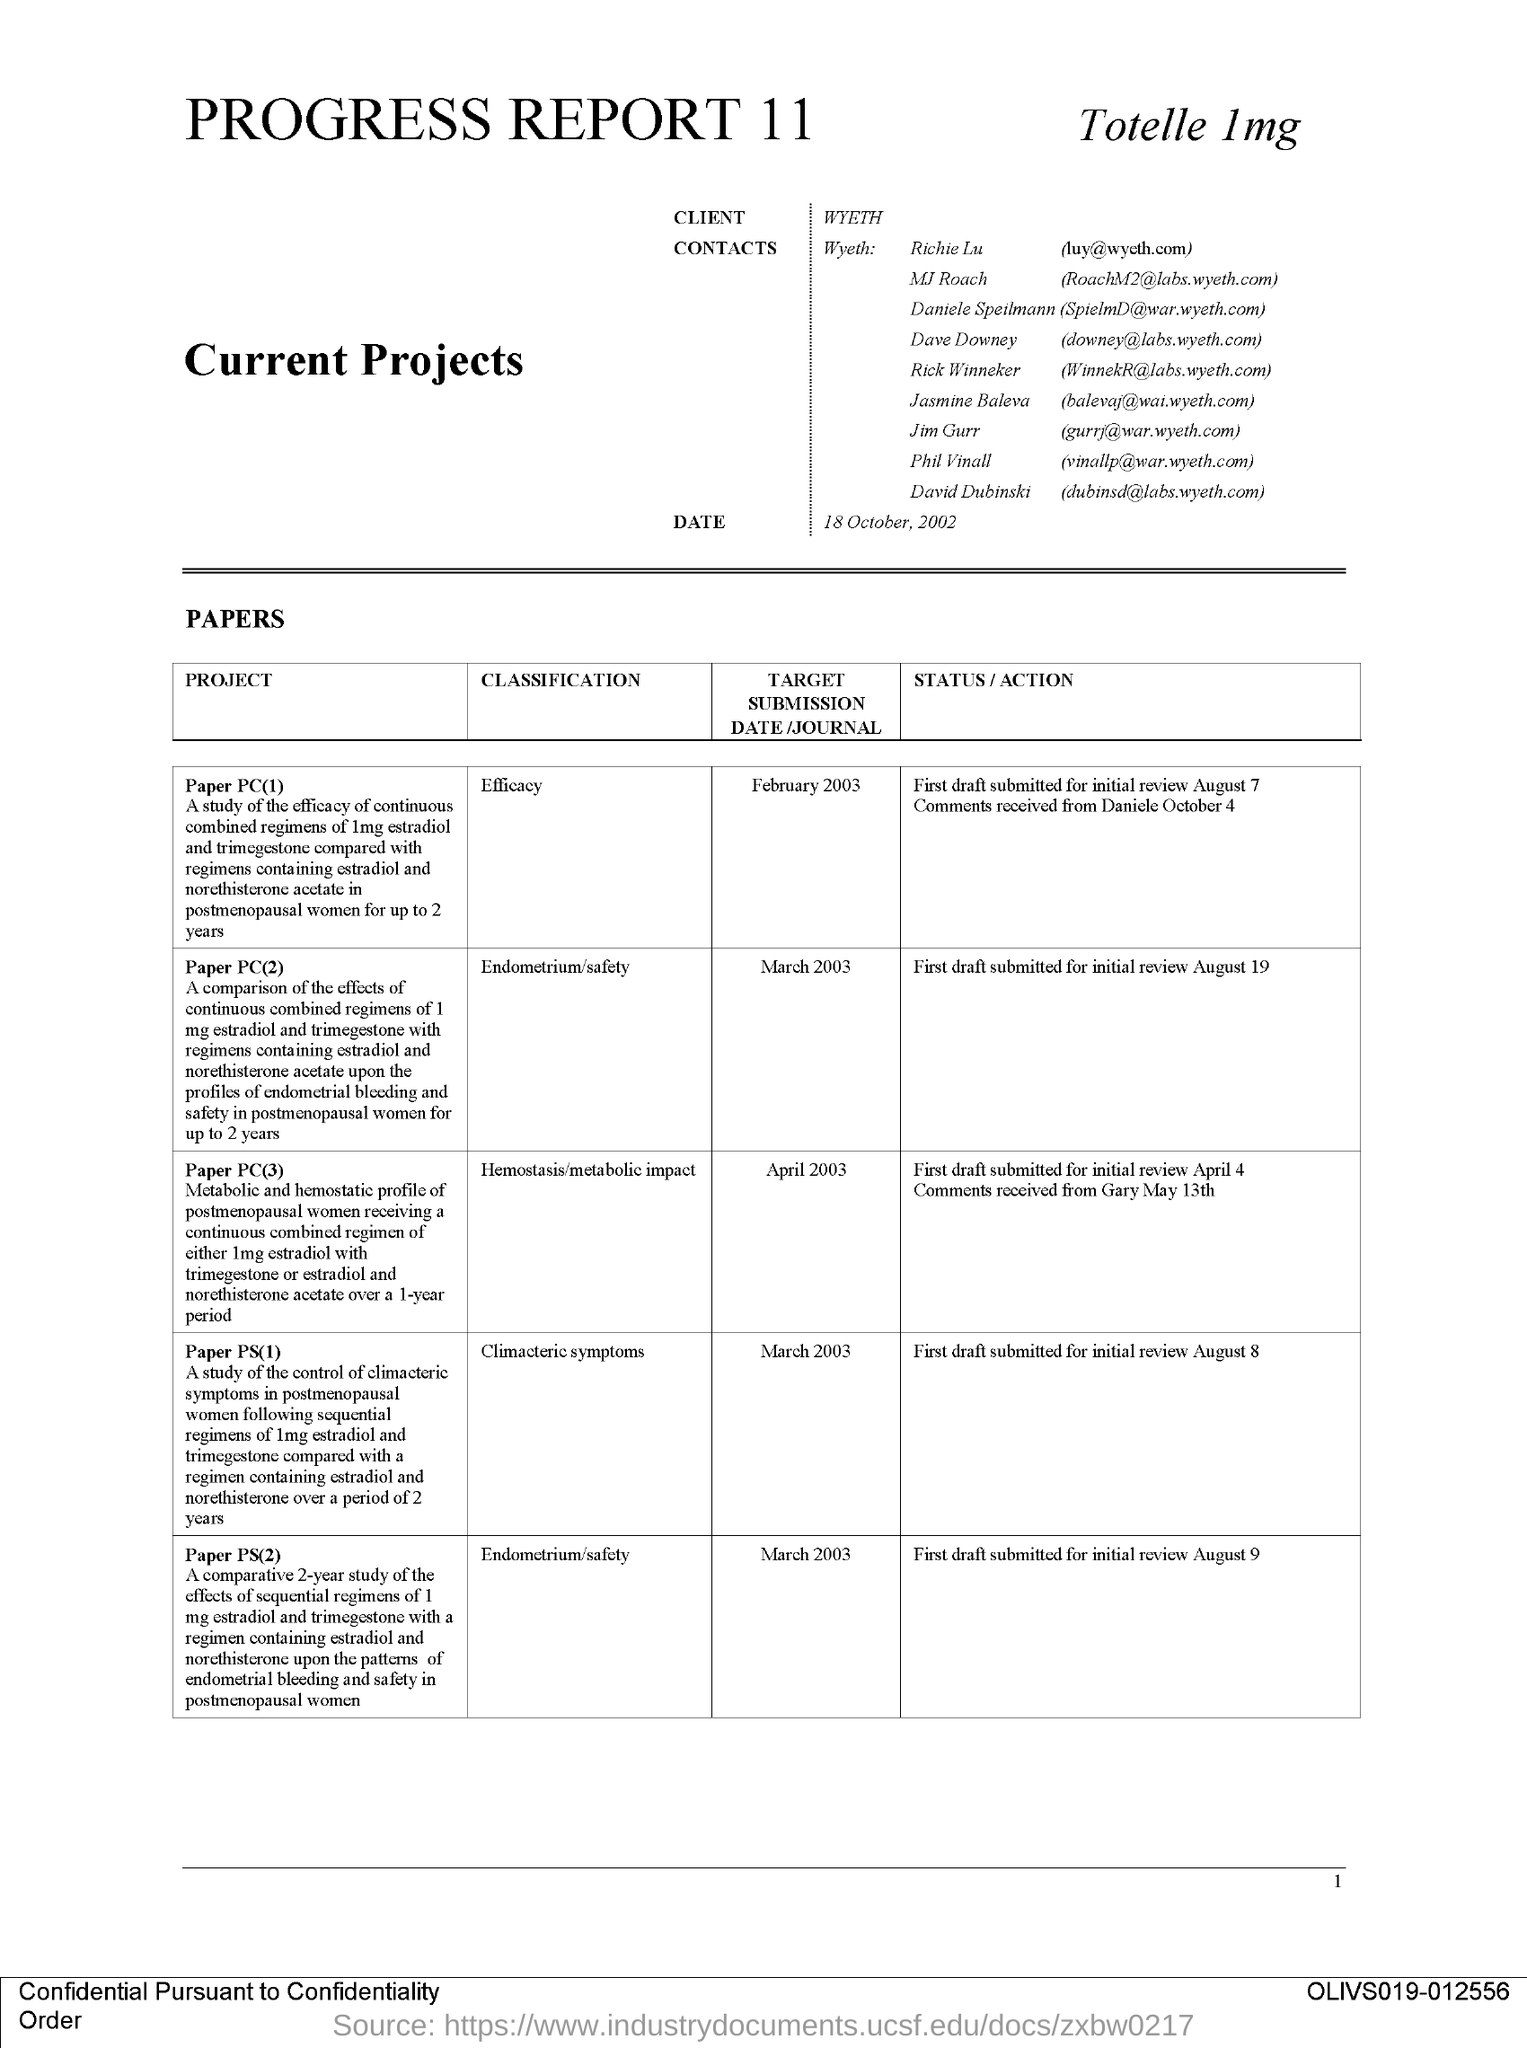What is the client name mentioned in this document?
Offer a very short reply. WYETH. What is the issued date of this document?
Your answer should be very brief. 18 October, 2002. What is the target submission date of the project 'Paper PC(2)'?
Provide a short and direct response. March 2003. What is the classification of the project 'Paper PC(2)'?
Provide a short and direct response. Endometrium/Safety. What is the target submission date of the project 'Paper PC(3)'?
Ensure brevity in your answer.  April 2003. 